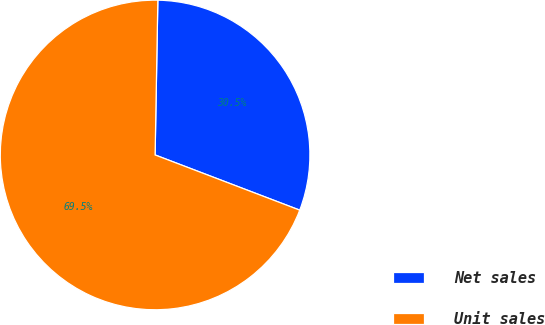Convert chart. <chart><loc_0><loc_0><loc_500><loc_500><pie_chart><fcel>Net sales<fcel>Unit sales<nl><fcel>30.52%<fcel>69.48%<nl></chart> 